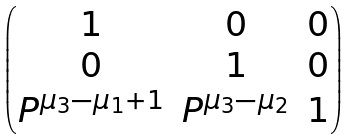<formula> <loc_0><loc_0><loc_500><loc_500>\begin{pmatrix} 1 & 0 & 0 \\ 0 & 1 & 0 \\ P ^ { \mu _ { 3 } - \mu _ { 1 } + 1 } & P ^ { \mu _ { 3 } - \mu _ { 2 } } & 1 \end{pmatrix}</formula> 